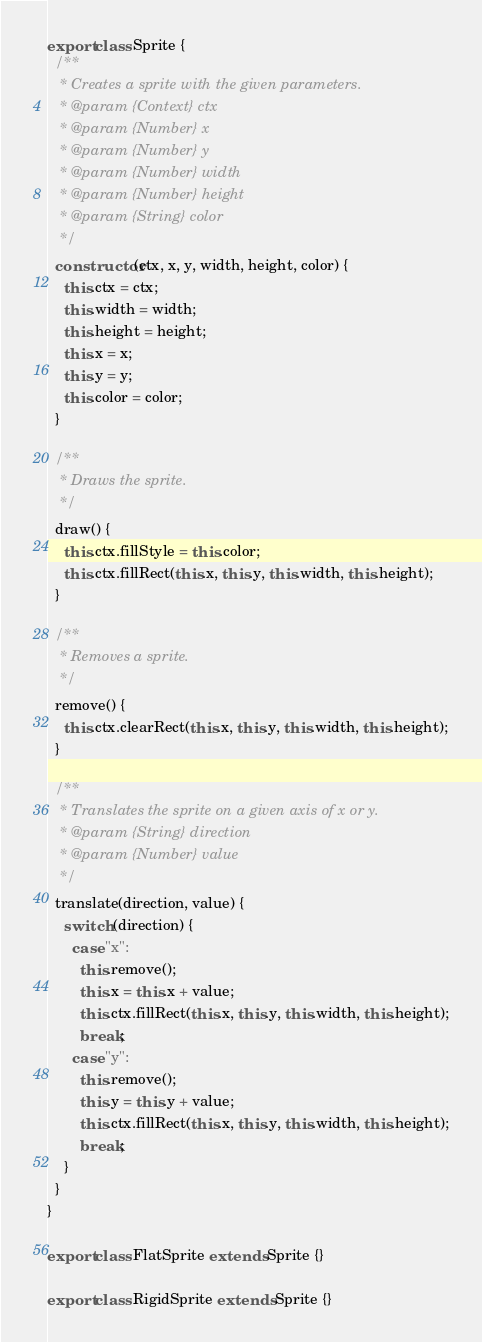Convert code to text. <code><loc_0><loc_0><loc_500><loc_500><_JavaScript_>export class Sprite {
  /**
   * Creates a sprite with the given parameters.
   * @param {Context} ctx
   * @param {Number} x
   * @param {Number} y
   * @param {Number} width
   * @param {Number} height
   * @param {String} color
   */
  constructor(ctx, x, y, width, height, color) {
    this.ctx = ctx;
    this.width = width;
    this.height = height;
    this.x = x;
    this.y = y;
    this.color = color;
  }

  /**
   * Draws the sprite.
   */
  draw() {
    this.ctx.fillStyle = this.color;
    this.ctx.fillRect(this.x, this.y, this.width, this.height);
  }

  /**
   * Removes a sprite.
   */
  remove() {
    this.ctx.clearRect(this.x, this.y, this.width, this.height);
  }

  /**
   * Translates the sprite on a given axis of x or y.
   * @param {String} direction
   * @param {Number} value
   */
  translate(direction, value) {
    switch (direction) {
      case "x":
        this.remove();
        this.x = this.x + value;
        this.ctx.fillRect(this.x, this.y, this.width, this.height);
        break;
      case "y":
        this.remove();
        this.y = this.y + value;
        this.ctx.fillRect(this.x, this.y, this.width, this.height);
        break;
    }
  }
}

export class FlatSprite extends Sprite {}

export class RigidSprite extends Sprite {}
</code> 